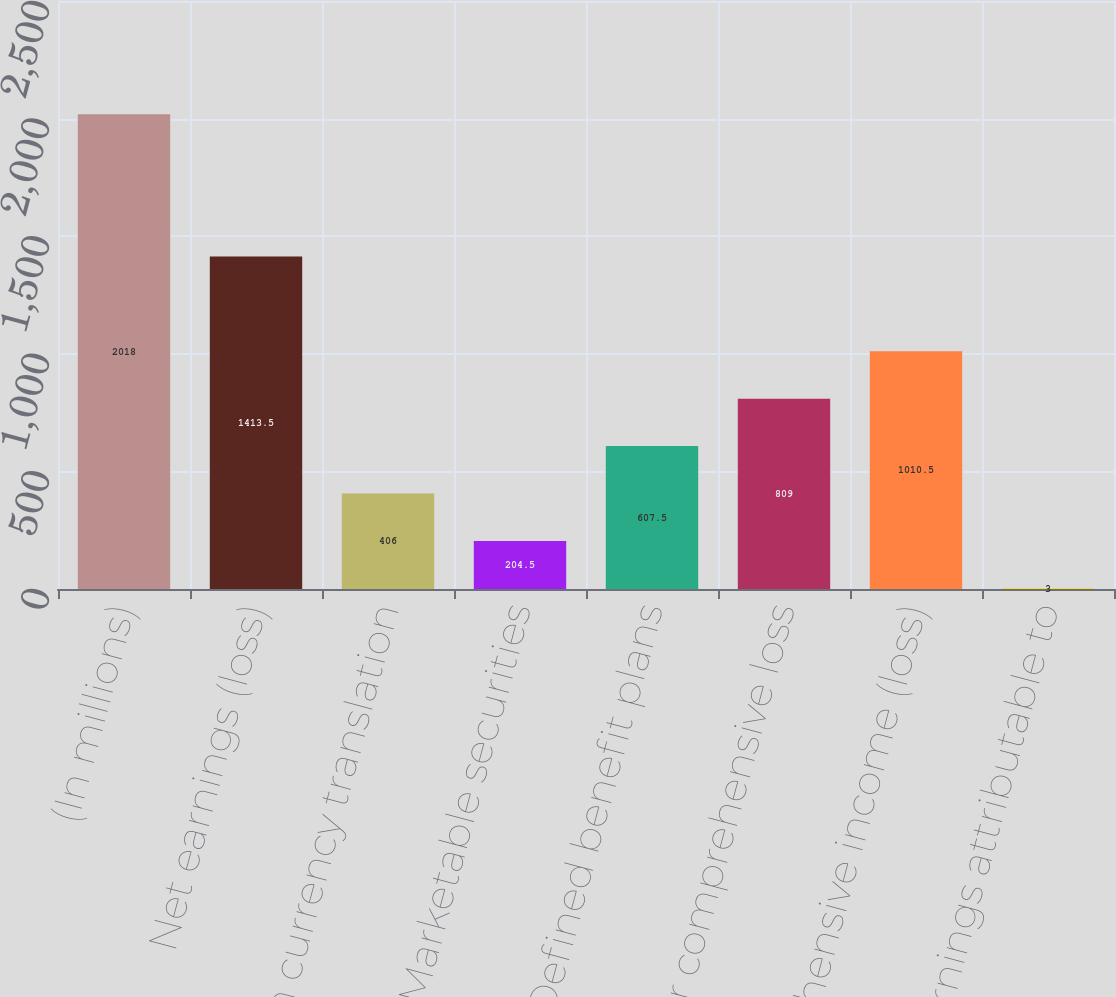<chart> <loc_0><loc_0><loc_500><loc_500><bar_chart><fcel>(In millions)<fcel>Net earnings (loss)<fcel>Foreign currency translation<fcel>Marketable securities<fcel>Defined benefit plans<fcel>Total other comprehensive loss<fcel>Comprehensive income (loss)<fcel>Less Earnings attributable to<nl><fcel>2018<fcel>1413.5<fcel>406<fcel>204.5<fcel>607.5<fcel>809<fcel>1010.5<fcel>3<nl></chart> 